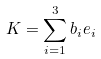Convert formula to latex. <formula><loc_0><loc_0><loc_500><loc_500>K = \sum _ { i = 1 } ^ { 3 } b _ { i } e _ { i }</formula> 